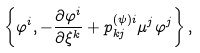<formula> <loc_0><loc_0><loc_500><loc_500>\left \{ \varphi ^ { i } , - \frac { \partial \varphi ^ { i } } { \partial \xi ^ { k } } + p _ { k j } ^ { ( \psi ) i } \mu ^ { j } \varphi ^ { j } \right \} ,</formula> 